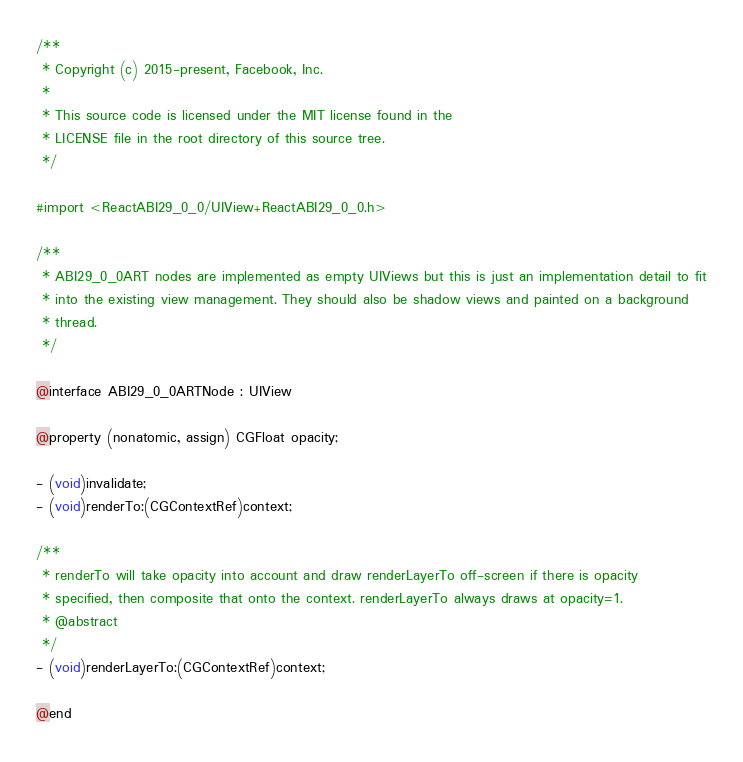<code> <loc_0><loc_0><loc_500><loc_500><_C_>/**
 * Copyright (c) 2015-present, Facebook, Inc.
 *
 * This source code is licensed under the MIT license found in the
 * LICENSE file in the root directory of this source tree.
 */

#import <ReactABI29_0_0/UIView+ReactABI29_0_0.h>

/**
 * ABI29_0_0ART nodes are implemented as empty UIViews but this is just an implementation detail to fit
 * into the existing view management. They should also be shadow views and painted on a background
 * thread.
 */

@interface ABI29_0_0ARTNode : UIView

@property (nonatomic, assign) CGFloat opacity;

- (void)invalidate;
- (void)renderTo:(CGContextRef)context;

/**
 * renderTo will take opacity into account and draw renderLayerTo off-screen if there is opacity
 * specified, then composite that onto the context. renderLayerTo always draws at opacity=1.
 * @abstract
 */
- (void)renderLayerTo:(CGContextRef)context;

@end
</code> 